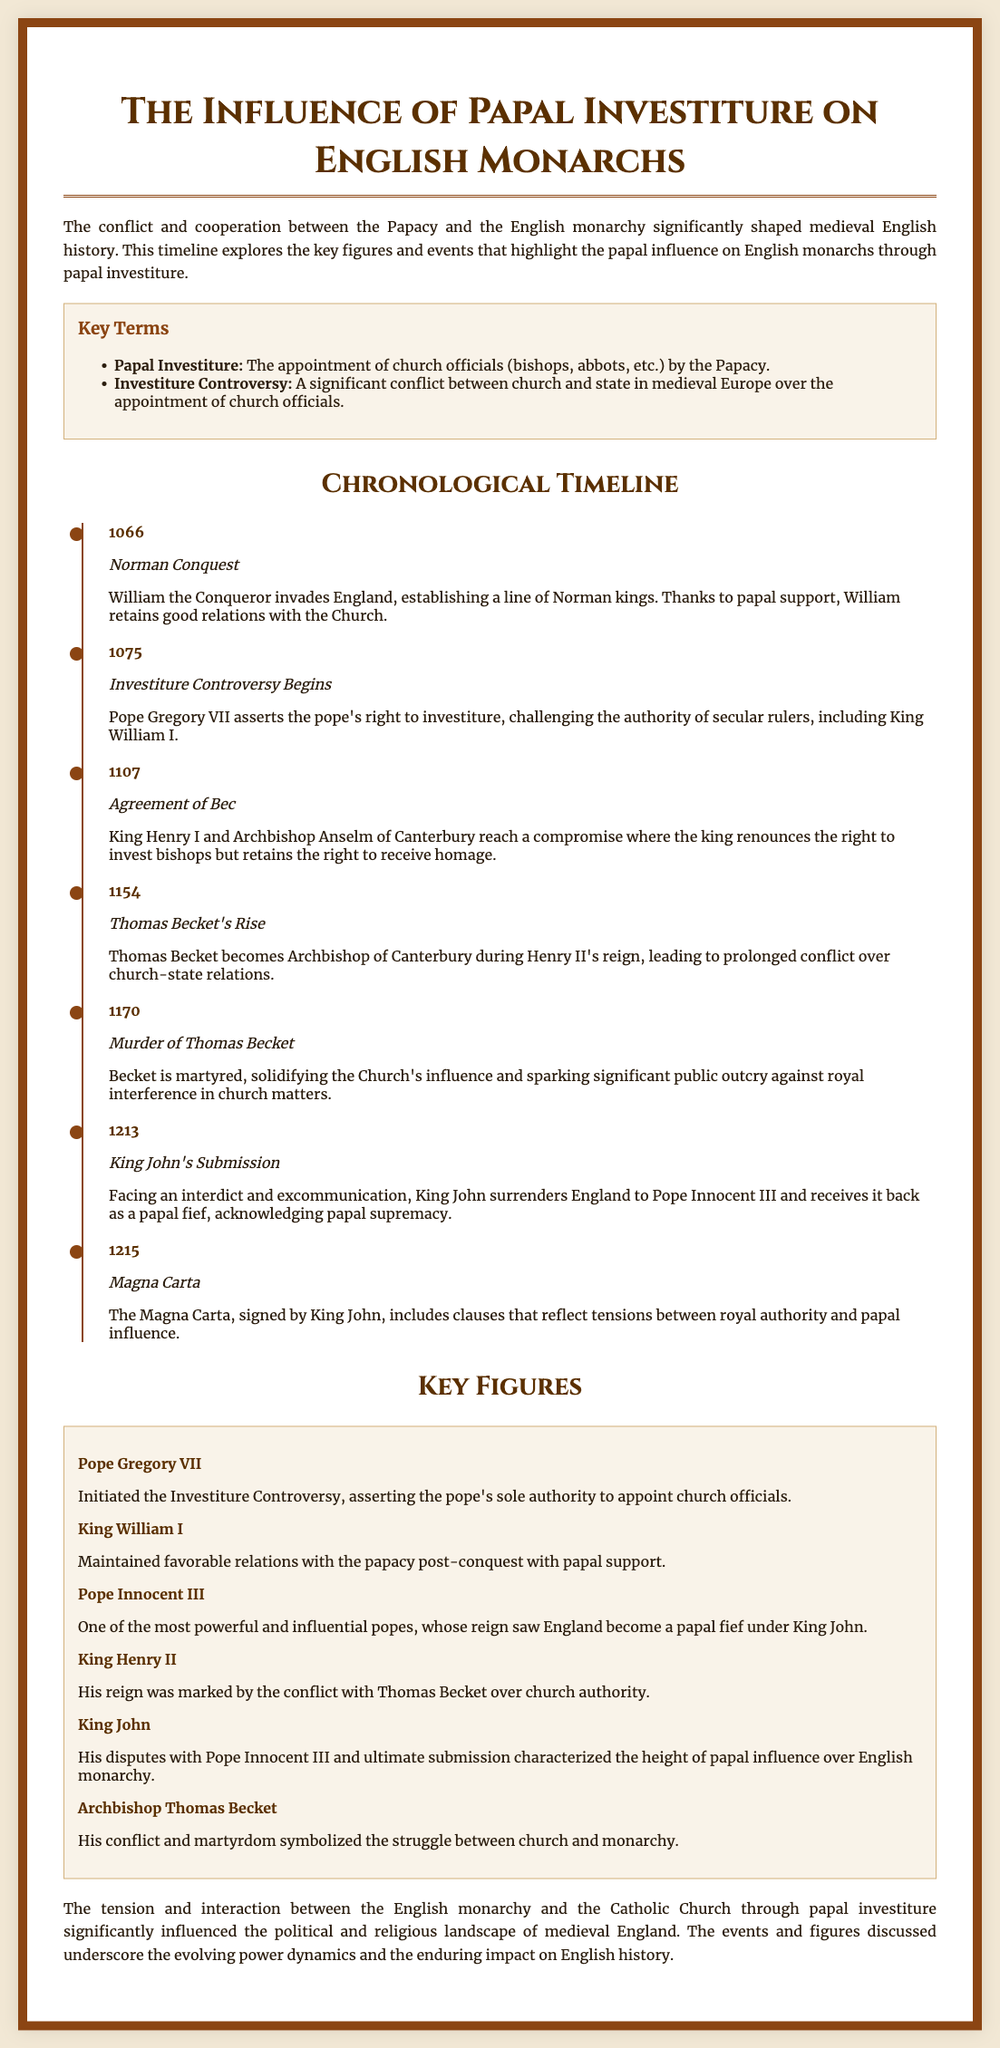What event marks the beginning of the Investiture Controversy? The document states that the Investiture Controversy begins in 1075, when Pope Gregory VII asserts the pope's right to investiture.
Answer: 1075 Who was the Archbishop of Canterbury during Henry II's reign? The document indicates that Thomas Becket becomes Archbishop of Canterbury during the reign of Henry II.
Answer: Thomas Becket What significant document was signed by King John in 1215? According to the document, the Magna Carta was signed by King John in 1215, reflecting tensions between royal authority and papal influence.
Answer: Magna Carta Which Pope asserted the pope's sole authority to appoint church officials? The document attributes the initiation of the Investiture Controversy to Pope Gregory VII, who asserted the pope's authority in appointments.
Answer: Pope Gregory VII What year did King John submit to Pope Innocent III? The document specifies that in 1213, King John surrenders England to Pope Innocent III, receiving it back as a papal fief.
Answer: 1213 What event involved the martyrdom of Thomas Becket? The document states that the murder of Thomas Becket in 1170 solidified the Church's influence and sparked public outcry.
Answer: Murder of Thomas Becket Which king maintained favorable relations with the papacy after the Norman Conquest? The text mentions that King William I, following the Norman Conquest in 1066, maintained favorable relations with the papacy.
Answer: King William I What was the compromise reached in 1107 called? The document refers to the 1107 agreement between King Henry I and Archbishop Anselm as the Agreement of Bec.
Answer: Agreement of Bec 